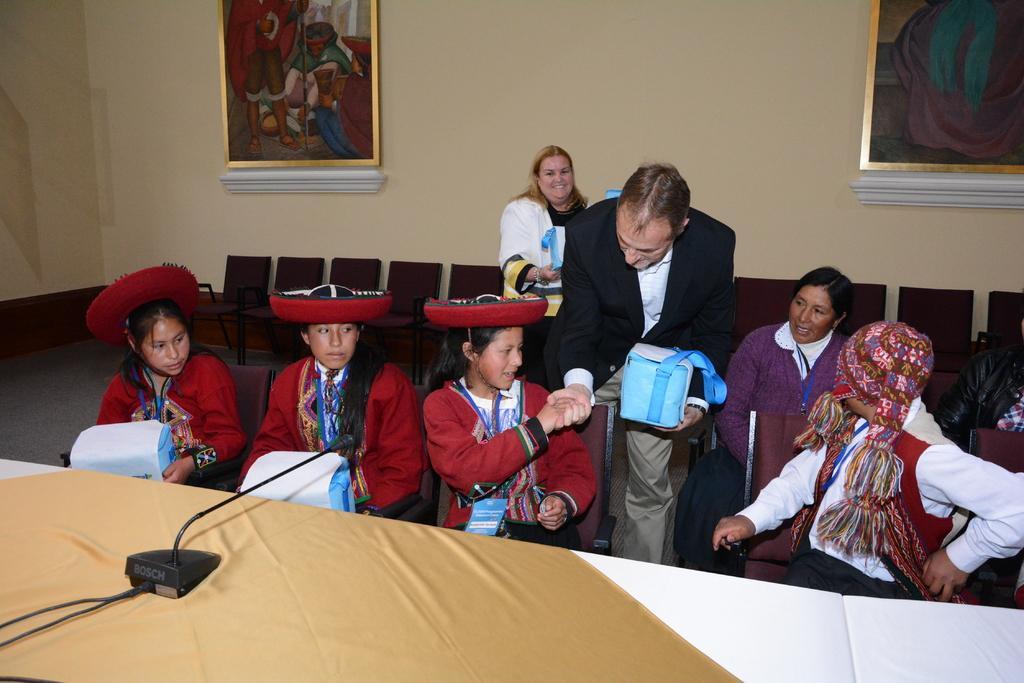Can you describe this image briefly? On the left side, there is a mic arranged on a light brown colored cloth which is on a table. Beside this table, there are persons sitting on chairs. One of them is shaking hands with a person who is in a suit and holding a box. Beside this person, there is a woman sitting and a person smiling, holding an object and standing. In the background, there are chairs arranged and there are photo frames attached to the wall. 